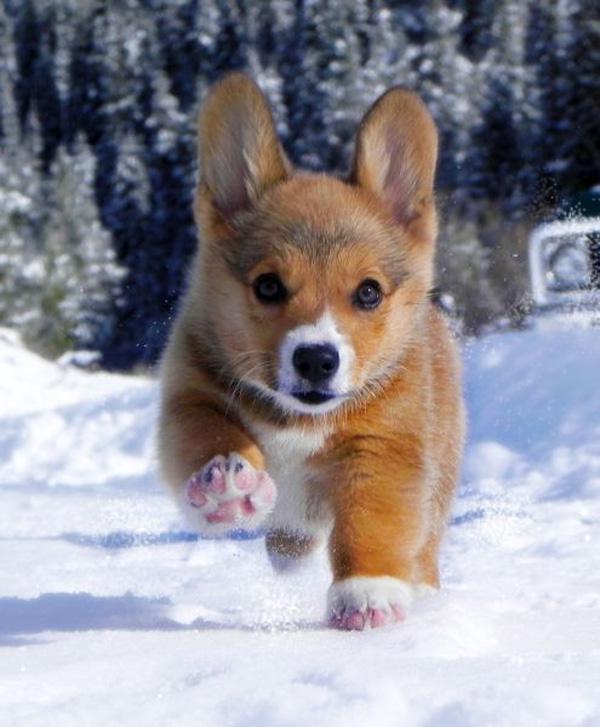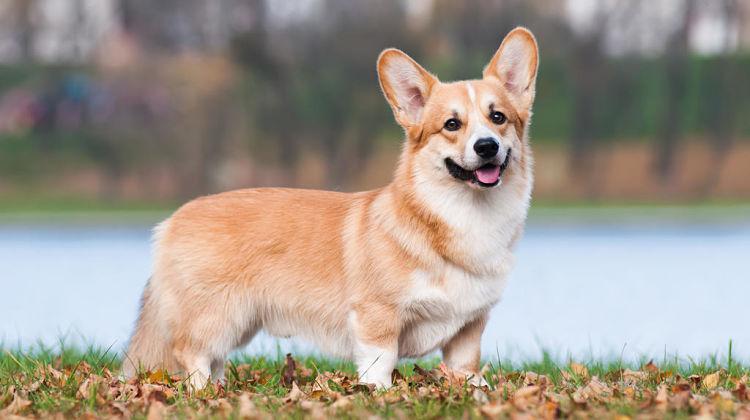The first image is the image on the left, the second image is the image on the right. Assess this claim about the two images: "There are exactly two dogs and both of them are outdoors.". Correct or not? Answer yes or no. Yes. The first image is the image on the left, the second image is the image on the right. Analyze the images presented: Is the assertion "All dogs are standing on all fours with their bodies aimed rightward, and at least one dog has its head turned to face the camera." valid? Answer yes or no. No. 